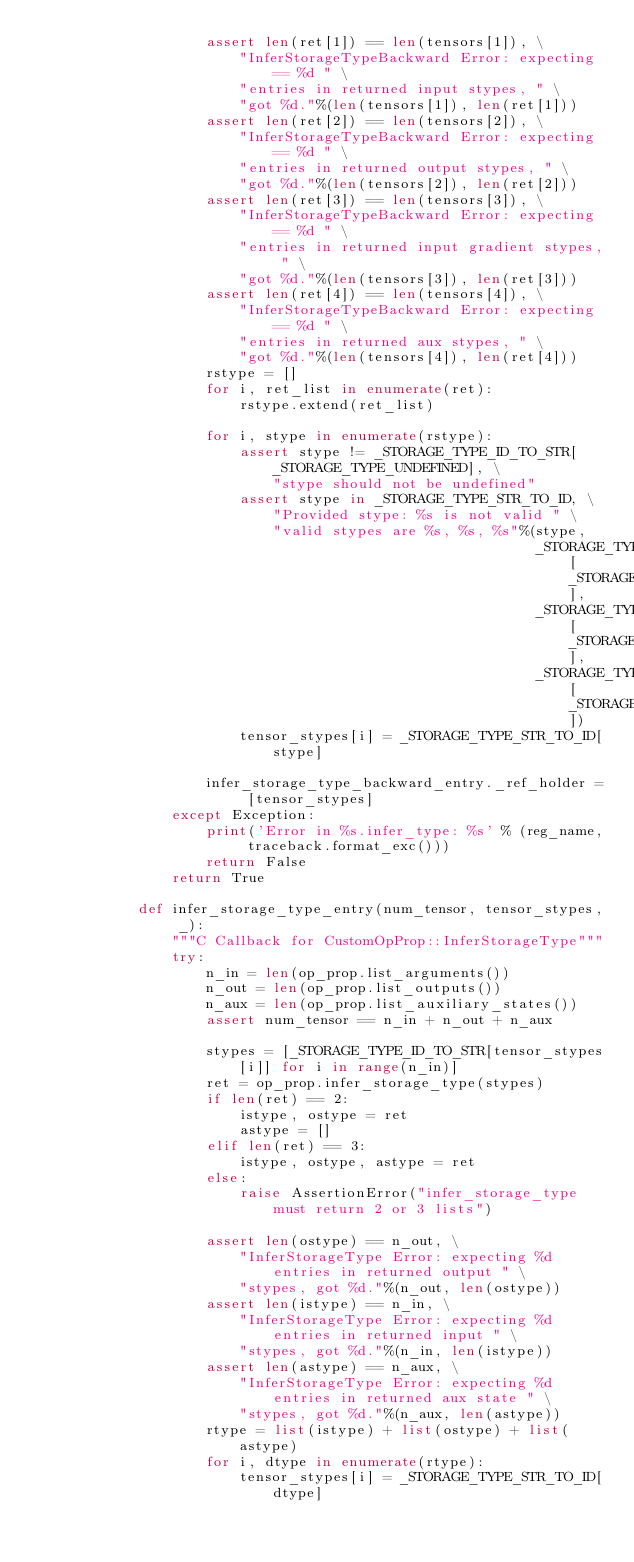<code> <loc_0><loc_0><loc_500><loc_500><_Python_>                    assert len(ret[1]) == len(tensors[1]), \
                        "InferStorageTypeBackward Error: expecting == %d " \
                        "entries in returned input stypes, " \
                        "got %d."%(len(tensors[1]), len(ret[1]))
                    assert len(ret[2]) == len(tensors[2]), \
                        "InferStorageTypeBackward Error: expecting == %d " \
                        "entries in returned output stypes, " \
                        "got %d."%(len(tensors[2]), len(ret[2]))
                    assert len(ret[3]) == len(tensors[3]), \
                        "InferStorageTypeBackward Error: expecting == %d " \
                        "entries in returned input gradient stypes, " \
                        "got %d."%(len(tensors[3]), len(ret[3]))
                    assert len(ret[4]) == len(tensors[4]), \
                        "InferStorageTypeBackward Error: expecting == %d " \
                        "entries in returned aux stypes, " \
                        "got %d."%(len(tensors[4]), len(ret[4]))
                    rstype = []
                    for i, ret_list in enumerate(ret):
                        rstype.extend(ret_list)

                    for i, stype in enumerate(rstype):
                        assert stype != _STORAGE_TYPE_ID_TO_STR[_STORAGE_TYPE_UNDEFINED], \
                            "stype should not be undefined"
                        assert stype in _STORAGE_TYPE_STR_TO_ID, \
                            "Provided stype: %s is not valid " \
                            "valid stypes are %s, %s, %s"%(stype,
                                                           _STORAGE_TYPE_ID_TO_STR[_STORAGE_TYPE_DEFAULT],
                                                           _STORAGE_TYPE_ID_TO_STR[_STORAGE_TYPE_ROW_SPARSE],
                                                           _STORAGE_TYPE_ID_TO_STR[_STORAGE_TYPE_CSR])
                        tensor_stypes[i] = _STORAGE_TYPE_STR_TO_ID[stype]

                    infer_storage_type_backward_entry._ref_holder = [tensor_stypes]
                except Exception:
                    print('Error in %s.infer_type: %s' % (reg_name, traceback.format_exc()))
                    return False
                return True

            def infer_storage_type_entry(num_tensor, tensor_stypes, _):
                """C Callback for CustomOpProp::InferStorageType"""
                try:
                    n_in = len(op_prop.list_arguments())
                    n_out = len(op_prop.list_outputs())
                    n_aux = len(op_prop.list_auxiliary_states())
                    assert num_tensor == n_in + n_out + n_aux

                    stypes = [_STORAGE_TYPE_ID_TO_STR[tensor_stypes[i]] for i in range(n_in)]
                    ret = op_prop.infer_storage_type(stypes)
                    if len(ret) == 2:
                        istype, ostype = ret
                        astype = []
                    elif len(ret) == 3:
                        istype, ostype, astype = ret
                    else:
                        raise AssertionError("infer_storage_type must return 2 or 3 lists")

                    assert len(ostype) == n_out, \
                        "InferStorageType Error: expecting %d entries in returned output " \
                        "stypes, got %d."%(n_out, len(ostype))
                    assert len(istype) == n_in, \
                        "InferStorageType Error: expecting %d entries in returned input " \
                        "stypes, got %d."%(n_in, len(istype))
                    assert len(astype) == n_aux, \
                        "InferStorageType Error: expecting %d entries in returned aux state " \
                        "stypes, got %d."%(n_aux, len(astype))
                    rtype = list(istype) + list(ostype) + list(astype)
                    for i, dtype in enumerate(rtype):
                        tensor_stypes[i] = _STORAGE_TYPE_STR_TO_ID[dtype]</code> 